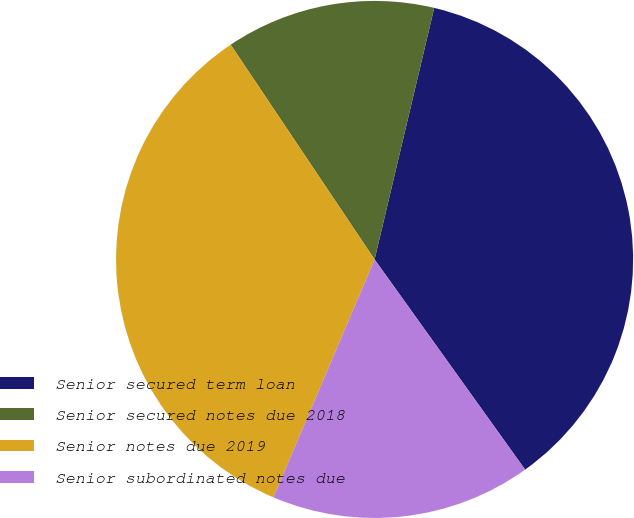Convert chart to OTSL. <chart><loc_0><loc_0><loc_500><loc_500><pie_chart><fcel>Senior secured term loan<fcel>Senior secured notes due 2018<fcel>Senior notes due 2019<fcel>Senior subordinated notes due<nl><fcel>36.4%<fcel>13.1%<fcel>34.2%<fcel>16.29%<nl></chart> 